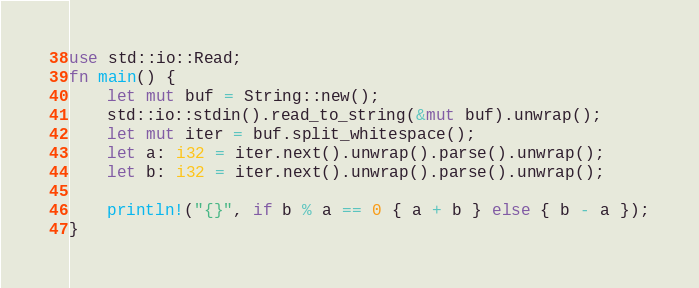Convert code to text. <code><loc_0><loc_0><loc_500><loc_500><_Rust_>use std::io::Read;
fn main() {
    let mut buf = String::new();
    std::io::stdin().read_to_string(&mut buf).unwrap();
    let mut iter = buf.split_whitespace();
    let a: i32 = iter.next().unwrap().parse().unwrap();
    let b: i32 = iter.next().unwrap().parse().unwrap();

    println!("{}", if b % a == 0 { a + b } else { b - a });
}
</code> 